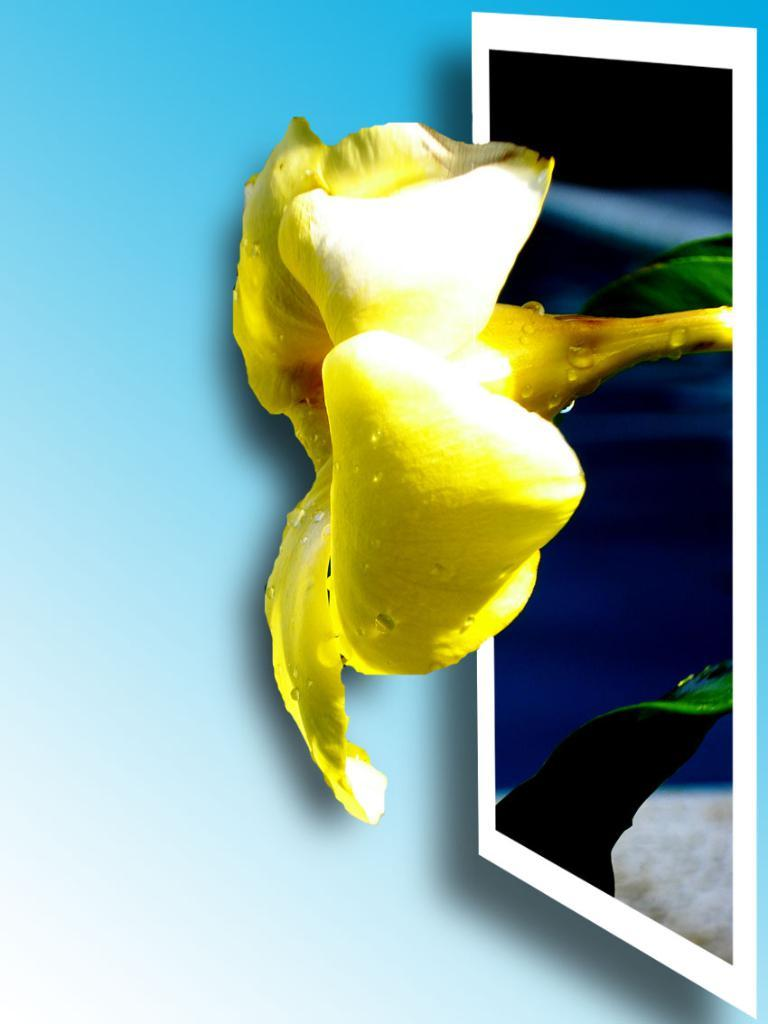What type of flower is in the image? There is a yellow flower in the image. What color are the leaves of the flower? The flower has green leaves. What color is the background of the image? The background of the image is blue. What type of haircut does the flower have in the image? The flower does not have a haircut, as it is a plant and not a person. 